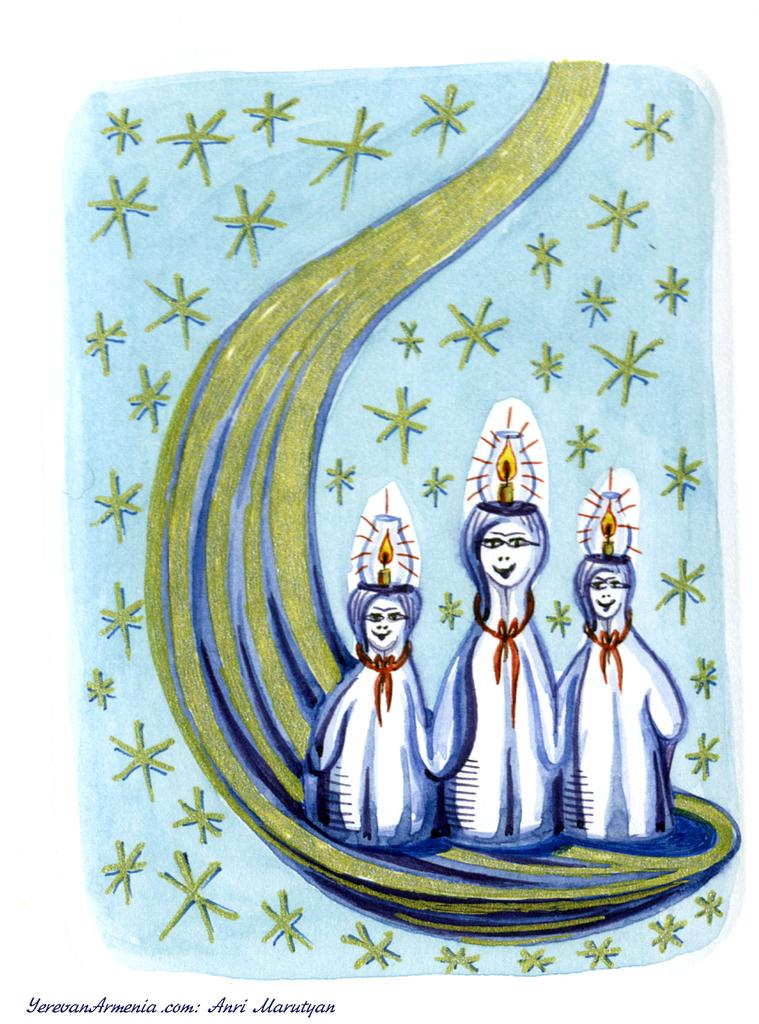What is the main subject of the image? There is a painting in the image. What is being depicted in the painting? The painting depicts people. Is there any text present in the painting? Yes, there is text on the bottom left of the painting. How many waves can be seen in the painting? There are no waves depicted in the painting; it features people and text. What color are the trousers worn by the people in the painting? The provided facts do not mention the color of any trousers worn by the people in the painting. 